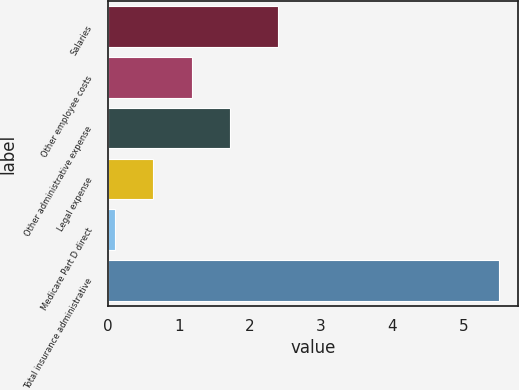Convert chart to OTSL. <chart><loc_0><loc_0><loc_500><loc_500><bar_chart><fcel>Salaries<fcel>Other employee costs<fcel>Other administrative expense<fcel>Legal expense<fcel>Medicare Part D direct<fcel>Total insurance administrative<nl><fcel>2.4<fcel>1.18<fcel>1.72<fcel>0.64<fcel>0.1<fcel>5.5<nl></chart> 